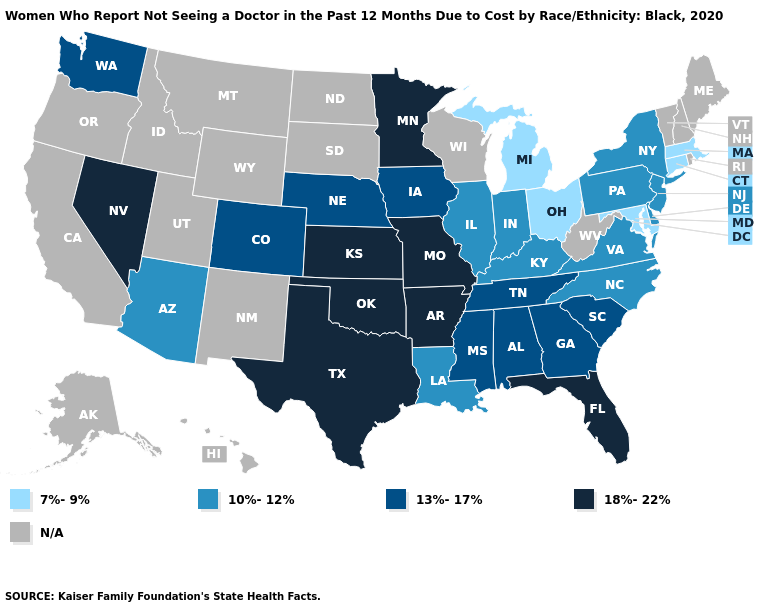What is the value of Kansas?
Answer briefly. 18%-22%. Name the states that have a value in the range 10%-12%?
Keep it brief. Arizona, Delaware, Illinois, Indiana, Kentucky, Louisiana, New Jersey, New York, North Carolina, Pennsylvania, Virginia. Does Minnesota have the highest value in the MidWest?
Short answer required. Yes. Does Georgia have the highest value in the South?
Keep it brief. No. What is the lowest value in the USA?
Short answer required. 7%-9%. Does Massachusetts have the lowest value in the Northeast?
Quick response, please. Yes. What is the value of Florida?
Write a very short answer. 18%-22%. Name the states that have a value in the range 18%-22%?
Give a very brief answer. Arkansas, Florida, Kansas, Minnesota, Missouri, Nevada, Oklahoma, Texas. Does Michigan have the highest value in the MidWest?
Quick response, please. No. Which states have the highest value in the USA?
Answer briefly. Arkansas, Florida, Kansas, Minnesota, Missouri, Nevada, Oklahoma, Texas. Among the states that border Vermont , which have the highest value?
Answer briefly. New York. Among the states that border Kentucky , does Missouri have the highest value?
Short answer required. Yes. Which states hav the highest value in the West?
Quick response, please. Nevada. What is the value of West Virginia?
Write a very short answer. N/A. 